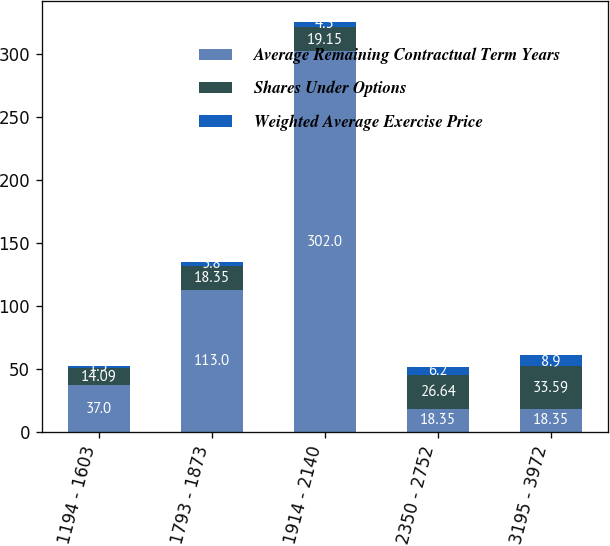Convert chart to OTSL. <chart><loc_0><loc_0><loc_500><loc_500><stacked_bar_chart><ecel><fcel>1194 - 1603<fcel>1793 - 1873<fcel>1914 - 2140<fcel>2350 - 2752<fcel>3195 - 3972<nl><fcel>Average Remaining Contractual Term Years<fcel>37<fcel>113<fcel>302<fcel>18.35<fcel>18.35<nl><fcel>Shares Under Options<fcel>14.09<fcel>18.35<fcel>19.15<fcel>26.64<fcel>33.59<nl><fcel>Weighted Average Exercise Price<fcel>1.5<fcel>3.8<fcel>4.3<fcel>6.2<fcel>8.9<nl></chart> 